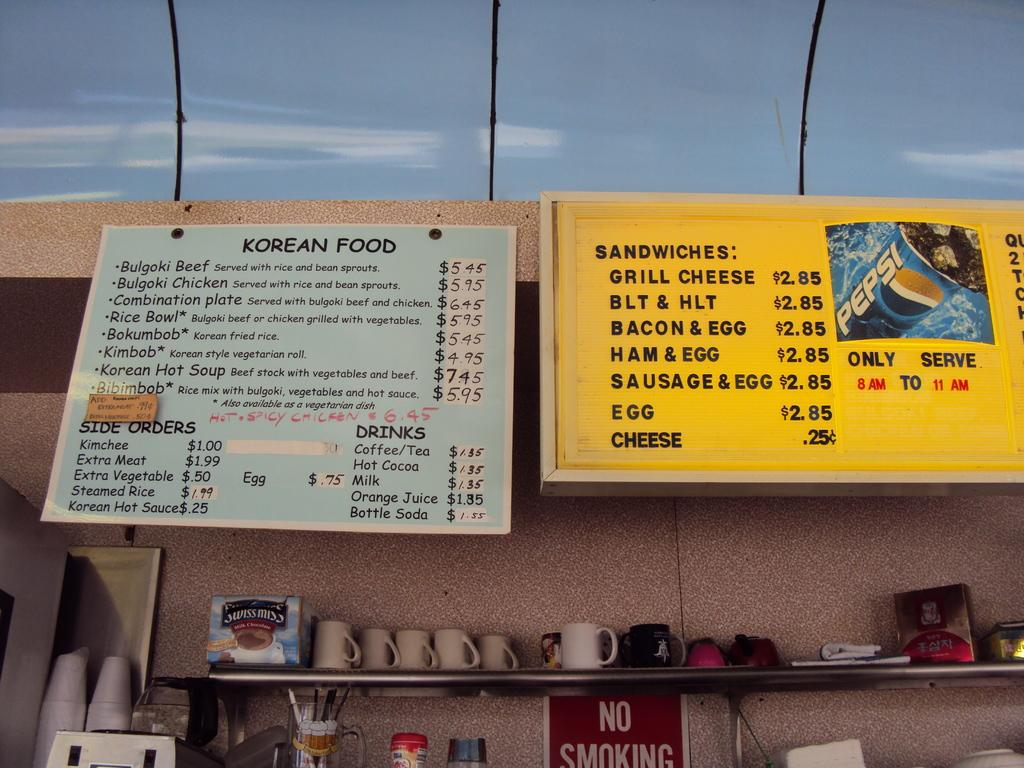<image>
Write a terse but informative summary of the picture. An outdoor display board menu for Korean food. 